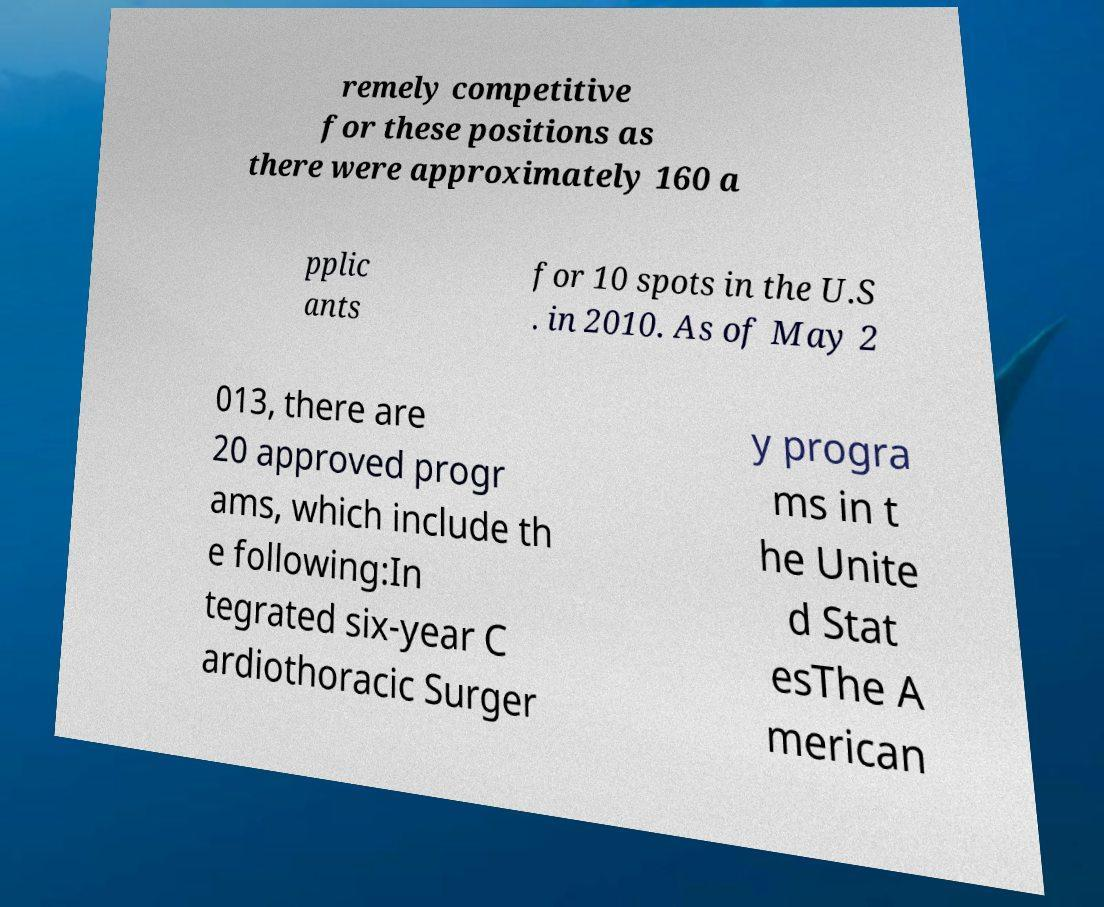Please identify and transcribe the text found in this image. remely competitive for these positions as there were approximately 160 a pplic ants for 10 spots in the U.S . in 2010. As of May 2 013, there are 20 approved progr ams, which include th e following:In tegrated six-year C ardiothoracic Surger y progra ms in t he Unite d Stat esThe A merican 